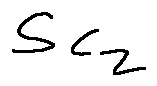<formula> <loc_0><loc_0><loc_500><loc_500>S _ { C _ { z } }</formula> 